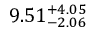<formula> <loc_0><loc_0><loc_500><loc_500>9 . 5 1 _ { - 2 . 0 6 } ^ { + 4 . 0 5 }</formula> 